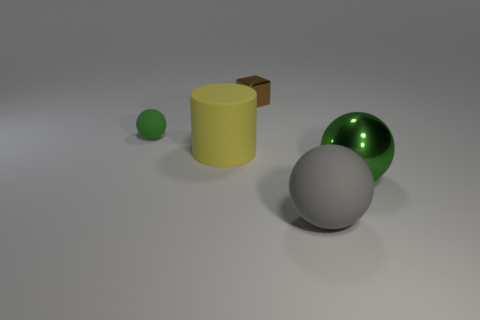There is another metal sphere that is the same color as the small ball; what size is it?
Your answer should be very brief. Large. There is a big ball that is the same color as the tiny matte thing; what is it made of?
Provide a succinct answer. Metal. Is there a green thing made of the same material as the tiny brown thing?
Your answer should be very brief. Yes. What number of objects are in front of the metallic cube and behind the big rubber cylinder?
Offer a terse response. 1. Are there fewer big objects that are to the left of the yellow object than gray spheres right of the shiny block?
Your answer should be very brief. Yes. Is the green rubber object the same shape as the big shiny object?
Offer a terse response. Yes. How many other things are there of the same size as the cylinder?
Your response must be concise. 2. What number of things are spheres that are left of the large gray rubber sphere or things that are in front of the brown block?
Offer a very short reply. 4. How many other objects are the same shape as the gray thing?
Your answer should be compact. 2. What is the thing that is right of the large cylinder and behind the big cylinder made of?
Your answer should be very brief. Metal. 